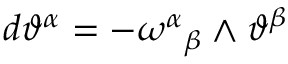<formula> <loc_0><loc_0><loc_500><loc_500>d \vartheta ^ { \alpha } = - \omega ^ { \alpha _ { \beta } \wedge \vartheta ^ { \beta }</formula> 